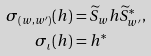<formula> <loc_0><loc_0><loc_500><loc_500>\sigma _ { ( w , w ^ { \prime } ) } ( h ) & = \widetilde { S } _ { w } h \widetilde { S } _ { w ^ { \prime } } ^ { * } , \\ \sigma _ { \iota } ( h ) & = h ^ { * }</formula> 